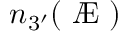Convert formula to latex. <formula><loc_0><loc_0><loc_500><loc_500>n _ { 3 ^ { \prime } } ( \ A E )</formula> 